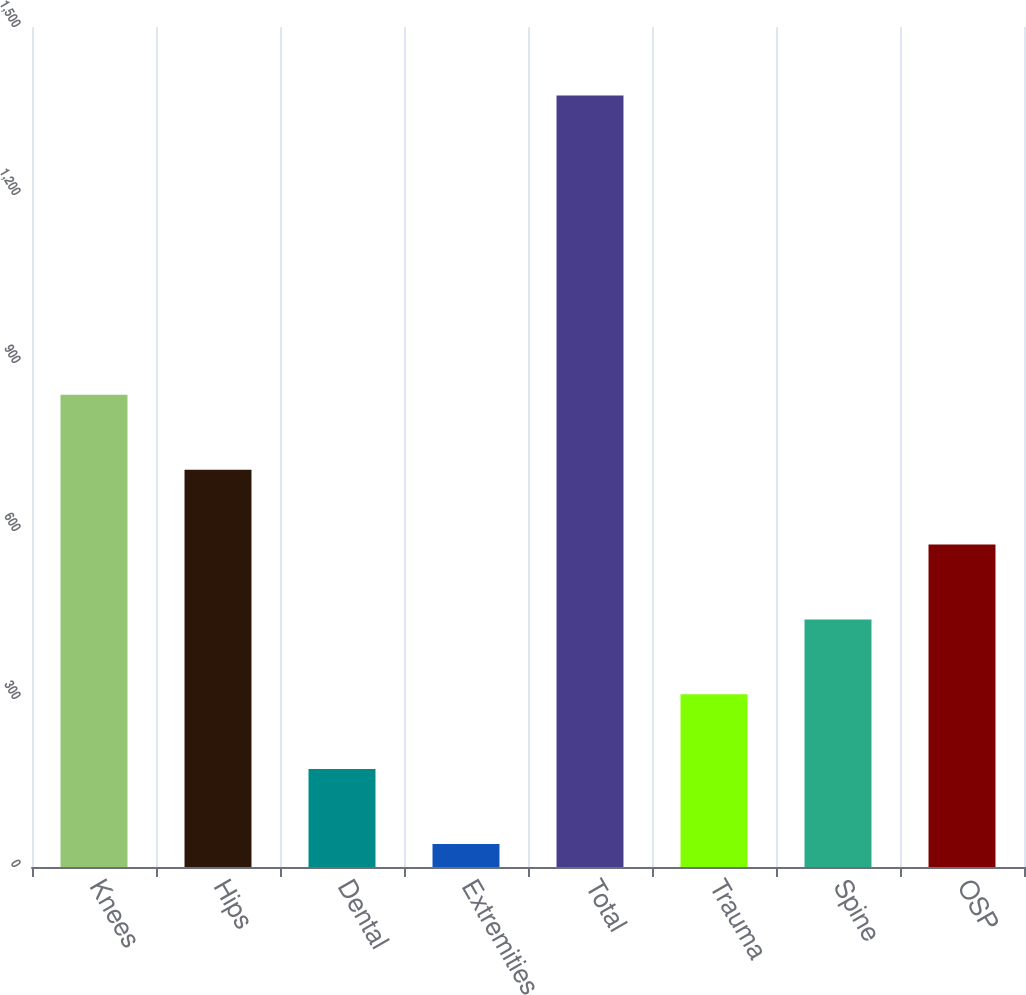Convert chart. <chart><loc_0><loc_0><loc_500><loc_500><bar_chart><fcel>Knees<fcel>Hips<fcel>Dental<fcel>Extremities<fcel>Total<fcel>Trauma<fcel>Spine<fcel>OSP<nl><fcel>843.18<fcel>709.5<fcel>174.78<fcel>41.1<fcel>1377.9<fcel>308.46<fcel>442.14<fcel>575.82<nl></chart> 